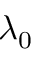<formula> <loc_0><loc_0><loc_500><loc_500>\lambda _ { 0 }</formula> 